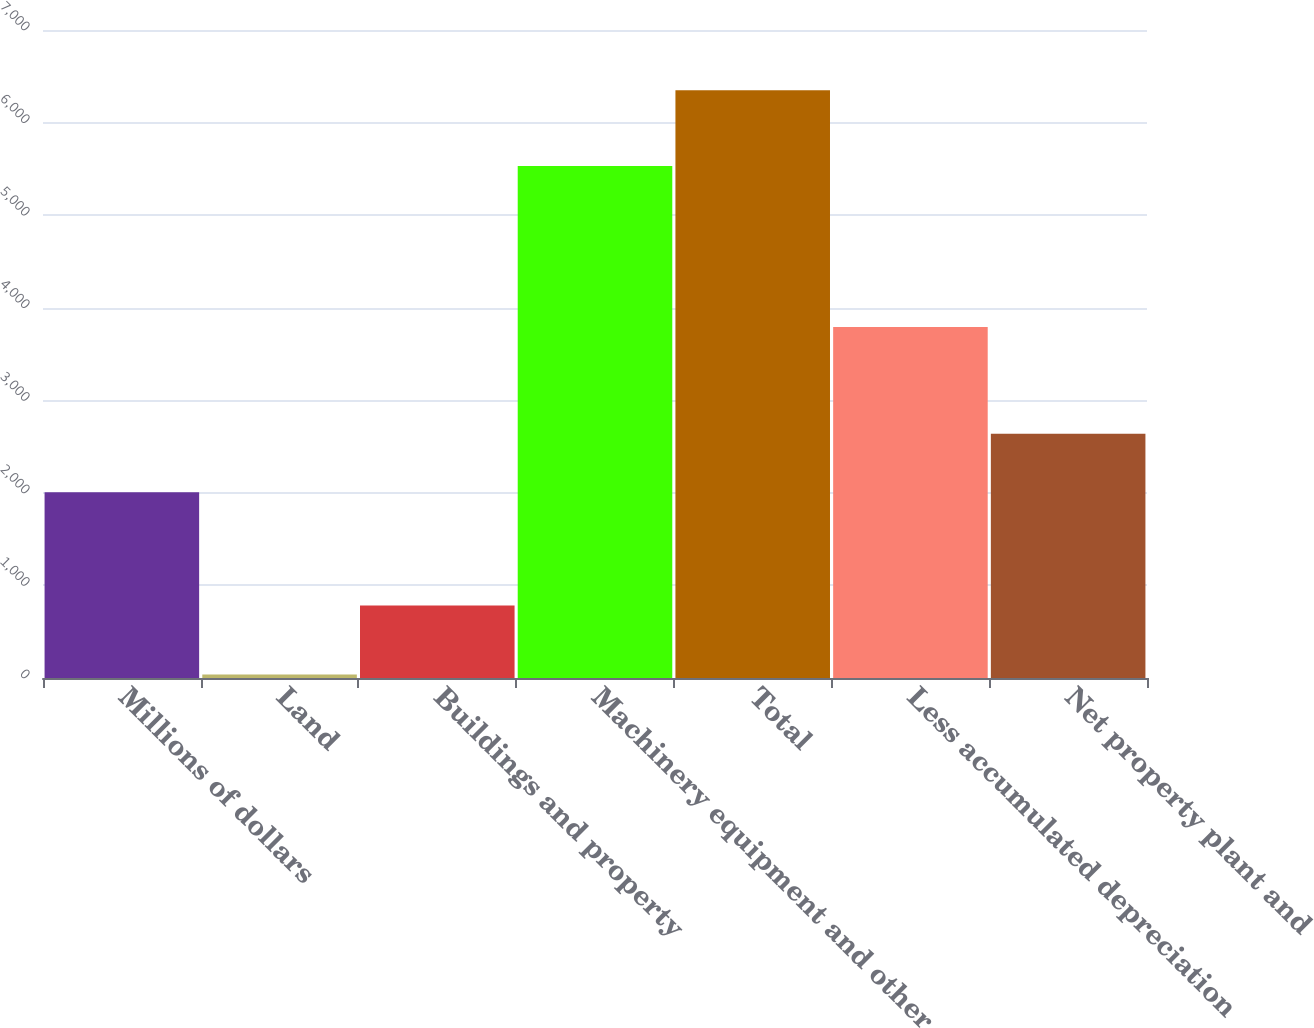Convert chart to OTSL. <chart><loc_0><loc_0><loc_500><loc_500><bar_chart><fcel>Millions of dollars<fcel>Land<fcel>Buildings and property<fcel>Machinery equipment and other<fcel>Total<fcel>Less accumulated depreciation<fcel>Net property plant and<nl><fcel>2006<fcel>37<fcel>782<fcel>5531<fcel>6350<fcel>3793<fcel>2637.3<nl></chart> 